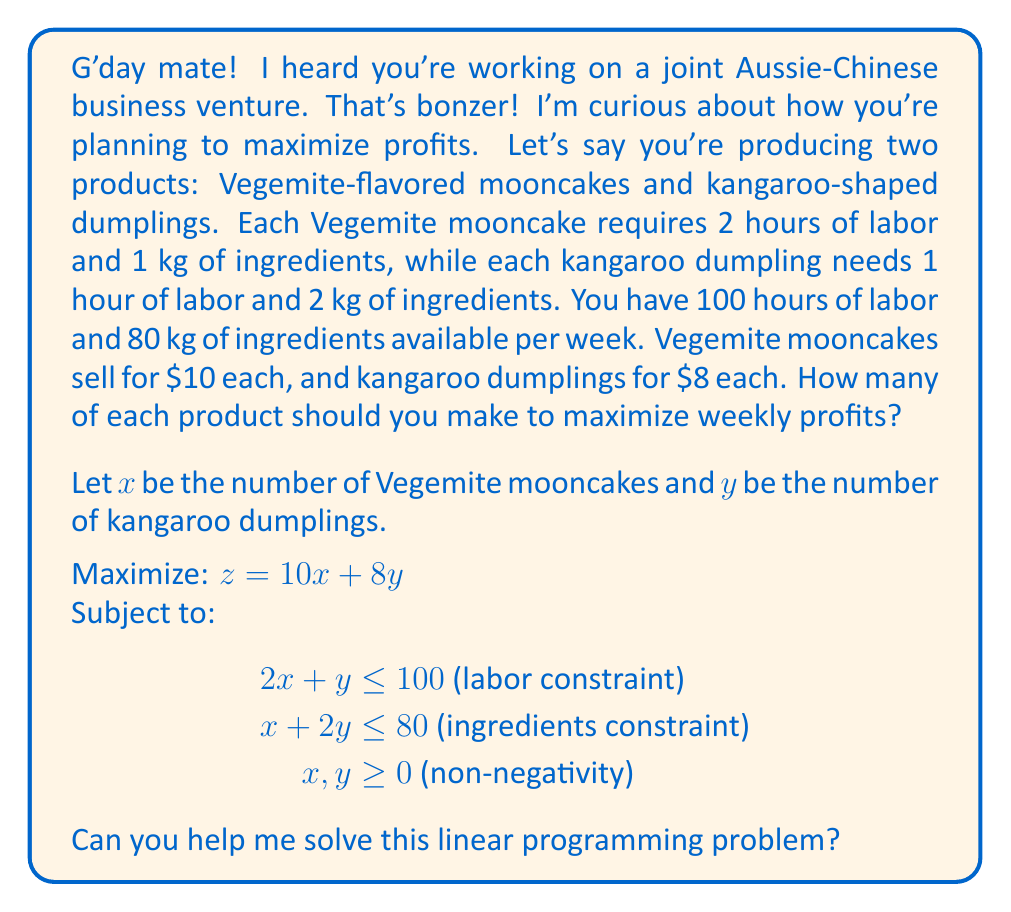Can you answer this question? To solve this linear programming problem, we'll use the graphical method:

1. Plot the constraints:
   - Labor constraint: $2x + y = 100$
   - Ingredients constraint: $x + 2y = 80$
   - Non-negativity constraints: $x \geq 0$, $y \geq 0$

2. Identify the feasible region (the area that satisfies all constraints).

3. Find the corner points of the feasible region:
   - (0, 0): Origin
   - (0, 40): Where ingredients constraint meets y-axis
   - (50, 0): Where labor constraint meets x-axis
   - Intersection of labor and ingredients constraints:
     Solve:
     $2x + y = 100$
     $x + 2y = 80$
     Subtracting the second equation from the first:
     $x - y = 20$
     Substituting into the first equation:
     $2(y + 20) + y = 100$
     $2y + 40 + y = 100$
     $3y = 60$
     $y = 20$
     $x = 40$
     So, the intersection point is (40, 20)

4. Evaluate the objective function at each corner point:
   - (0, 0): $z = 10(0) + 8(0) = 0$
   - (0, 40): $z = 10(0) + 8(40) = 320$
   - (50, 0): $z = 10(50) + 8(0) = 500$
   - (40, 20): $z = 10(40) + 8(20) = 560$

5. The maximum value of the objective function occurs at the point (40, 20).

Therefore, to maximize weekly profits, the business should produce 40 Vegemite mooncakes and 20 kangaroo dumplings.
Answer: The optimal solution is to produce 40 Vegemite mooncakes and 20 kangaroo dumplings per week, resulting in a maximum profit of $560. 